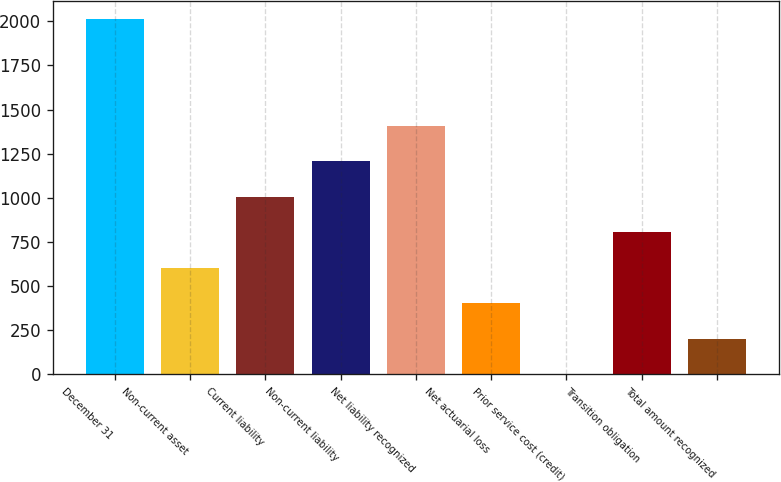<chart> <loc_0><loc_0><loc_500><loc_500><bar_chart><fcel>December 31<fcel>Non-current asset<fcel>Current liability<fcel>Non-current liability<fcel>Net liability recognized<fcel>Net actuarial loss<fcel>Prior service cost (credit)<fcel>Transition obligation<fcel>Total amount recognized<nl><fcel>2012<fcel>603.74<fcel>1006.1<fcel>1207.28<fcel>1408.46<fcel>402.56<fcel>0.2<fcel>804.92<fcel>201.38<nl></chart> 